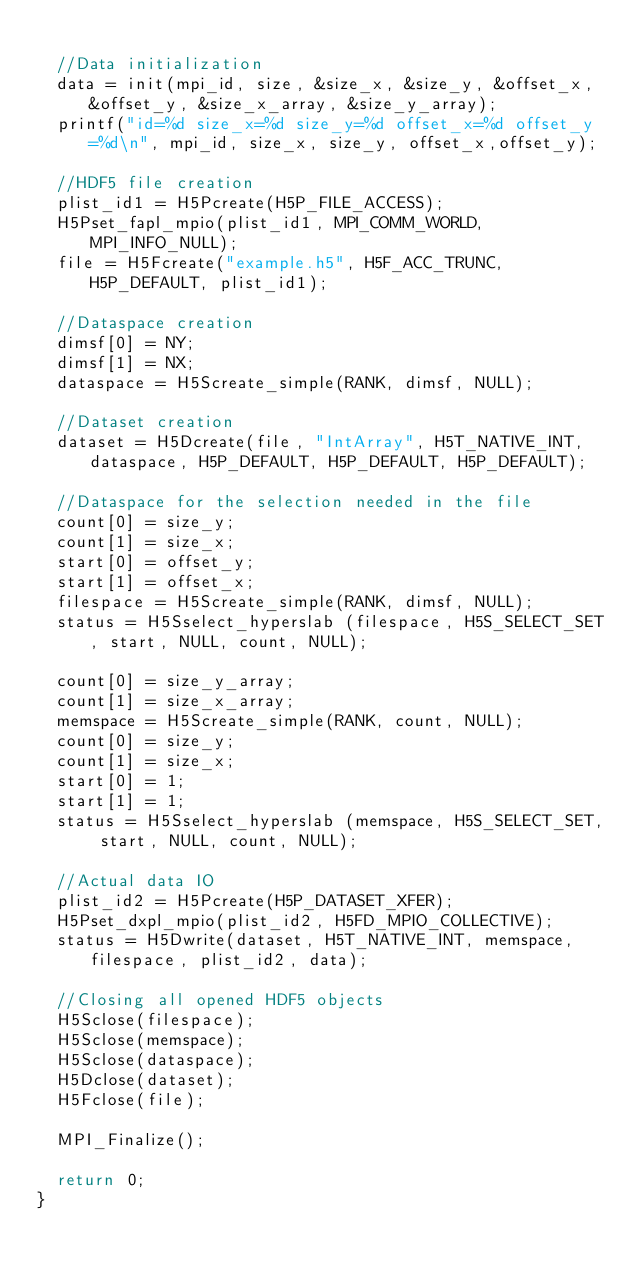Convert code to text. <code><loc_0><loc_0><loc_500><loc_500><_C_>
  //Data initialization
  data = init(mpi_id, size, &size_x, &size_y, &offset_x, &offset_y, &size_x_array, &size_y_array);
  printf("id=%d size_x=%d size_y=%d offset_x=%d offset_y=%d\n", mpi_id, size_x, size_y, offset_x,offset_y);
  
  //HDF5 file creation
  plist_id1 = H5Pcreate(H5P_FILE_ACCESS);
  H5Pset_fapl_mpio(plist_id1, MPI_COMM_WORLD, MPI_INFO_NULL);
  file = H5Fcreate("example.h5", H5F_ACC_TRUNC, H5P_DEFAULT, plist_id1);

  //Dataspace creation
  dimsf[0] = NY;
  dimsf[1] = NX;
  dataspace = H5Screate_simple(RANK, dimsf, NULL); 

  //Dataset creation 
  dataset = H5Dcreate(file, "IntArray", H5T_NATIVE_INT, dataspace, H5P_DEFAULT, H5P_DEFAULT, H5P_DEFAULT);

  //Dataspace for the selection needed in the file
  count[0] = size_y;
  count[1] = size_x;
  start[0] = offset_y;
  start[1] = offset_x;
  filespace = H5Screate_simple(RANK, dimsf, NULL);
  status = H5Sselect_hyperslab (filespace, H5S_SELECT_SET, start, NULL, count, NULL);

  count[0] = size_y_array;
  count[1] = size_x_array;
  memspace = H5Screate_simple(RANK, count, NULL);
  count[0] = size_y;
  count[1] = size_x;
  start[0] = 1;
  start[1] = 1;
  status = H5Sselect_hyperslab (memspace, H5S_SELECT_SET, start, NULL, count, NULL);

  //Actual data IO
  plist_id2 = H5Pcreate(H5P_DATASET_XFER);
  H5Pset_dxpl_mpio(plist_id2, H5FD_MPIO_COLLECTIVE);
  status = H5Dwrite(dataset, H5T_NATIVE_INT, memspace, filespace, plist_id2, data);

  //Closing all opened HDF5 objects
  H5Sclose(filespace);
  H5Sclose(memspace);
  H5Sclose(dataspace);
  H5Dclose(dataset);
  H5Fclose(file);
  
  MPI_Finalize();

  return 0;
}     
</code> 